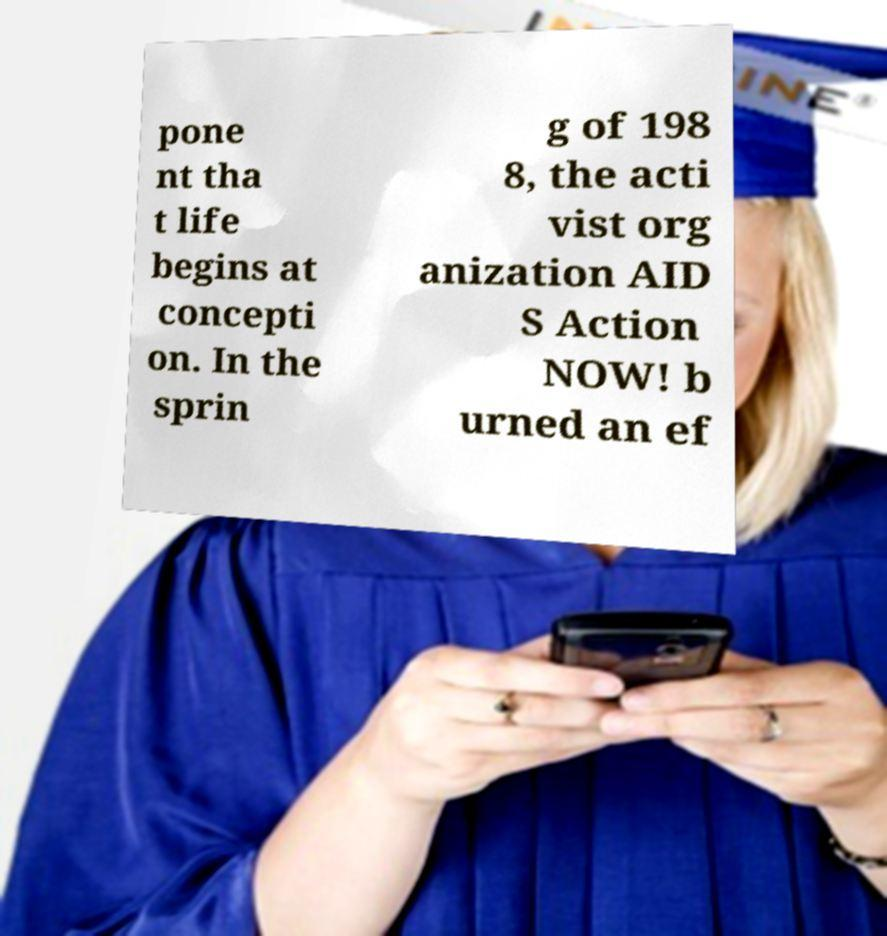Please identify and transcribe the text found in this image. pone nt tha t life begins at concepti on. In the sprin g of 198 8, the acti vist org anization AID S Action NOW! b urned an ef 